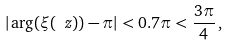<formula> <loc_0><loc_0><loc_500><loc_500>| \arg ( \xi ( \ z ) ) - \pi | < 0 . 7 \pi < \frac { 3 \pi } { 4 } \, ,</formula> 